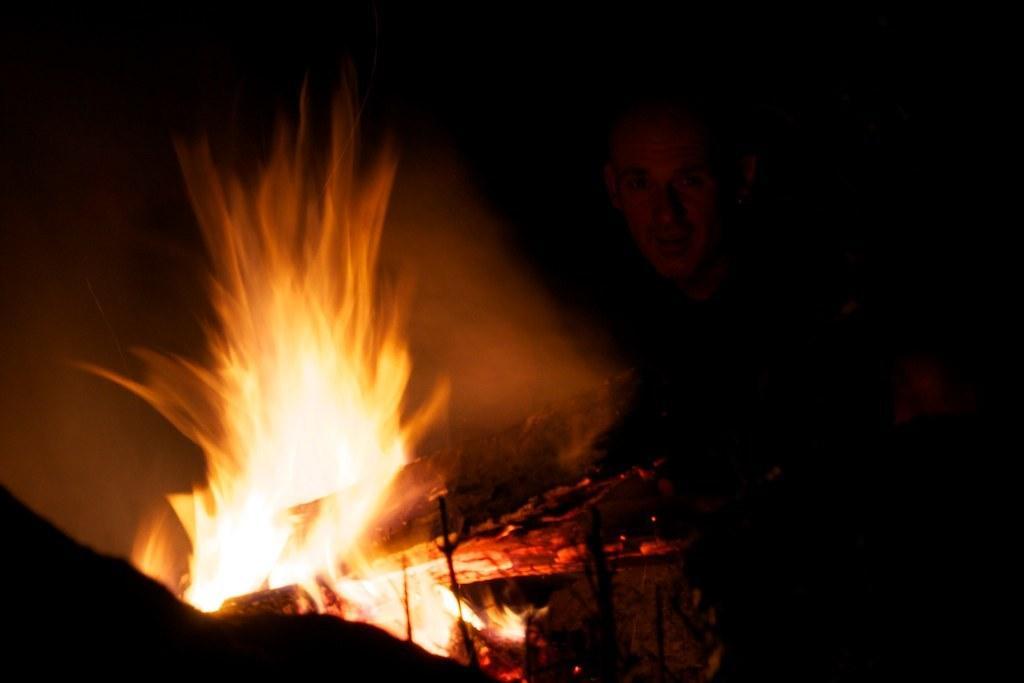In one or two sentences, can you explain what this image depicts? In this image a person is behind the fire camp. 